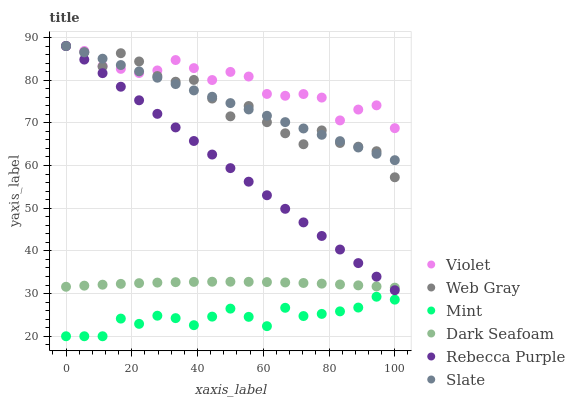Does Mint have the minimum area under the curve?
Answer yes or no. Yes. Does Violet have the maximum area under the curve?
Answer yes or no. Yes. Does Slate have the minimum area under the curve?
Answer yes or no. No. Does Slate have the maximum area under the curve?
Answer yes or no. No. Is Rebecca Purple the smoothest?
Answer yes or no. Yes. Is Web Gray the roughest?
Answer yes or no. Yes. Is Slate the smoothest?
Answer yes or no. No. Is Slate the roughest?
Answer yes or no. No. Does Mint have the lowest value?
Answer yes or no. Yes. Does Slate have the lowest value?
Answer yes or no. No. Does Violet have the highest value?
Answer yes or no. Yes. Does Dark Seafoam have the highest value?
Answer yes or no. No. Is Mint less than Slate?
Answer yes or no. Yes. Is Violet greater than Mint?
Answer yes or no. Yes. Does Web Gray intersect Rebecca Purple?
Answer yes or no. Yes. Is Web Gray less than Rebecca Purple?
Answer yes or no. No. Is Web Gray greater than Rebecca Purple?
Answer yes or no. No. Does Mint intersect Slate?
Answer yes or no. No. 